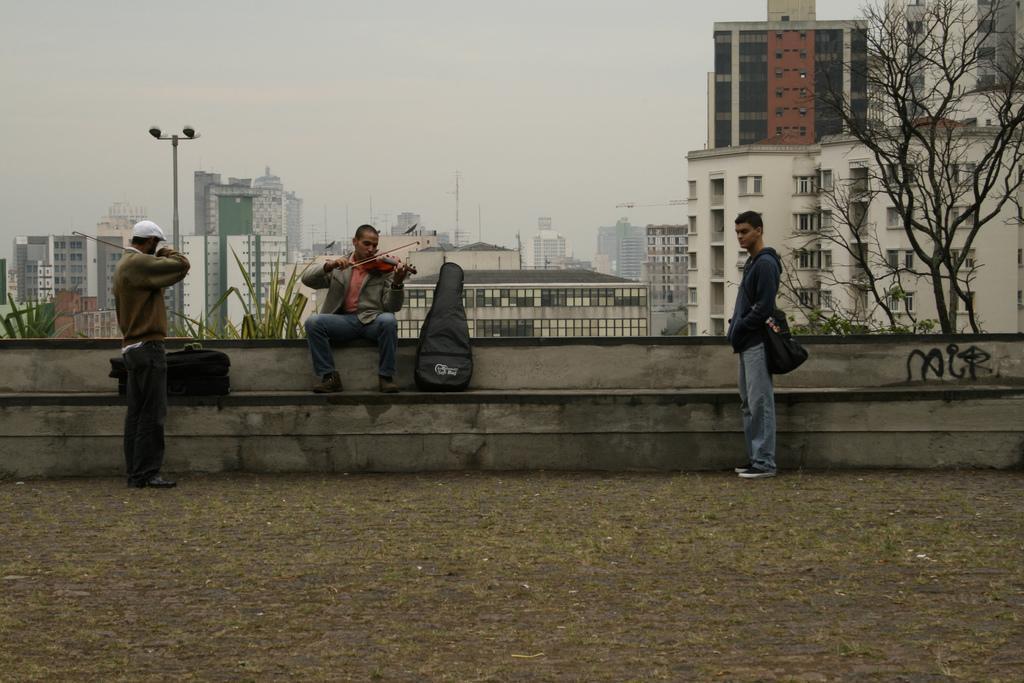Please provide a concise description of this image. In this image, there are two persons standing and wearing clothes. There is an another person in the middle of the image playing a violin and sitting in front of buildings. There is a tree in the top right of the image. There is a sky at the top of the image. 